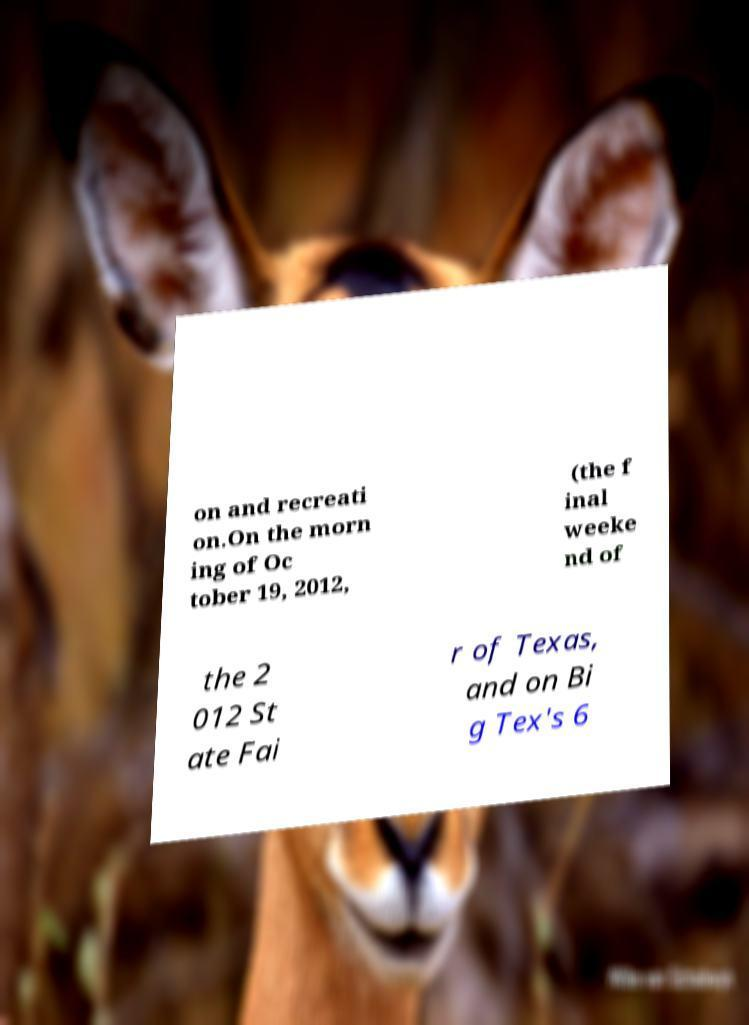There's text embedded in this image that I need extracted. Can you transcribe it verbatim? on and recreati on.On the morn ing of Oc tober 19, 2012, (the f inal weeke nd of the 2 012 St ate Fai r of Texas, and on Bi g Tex's 6 